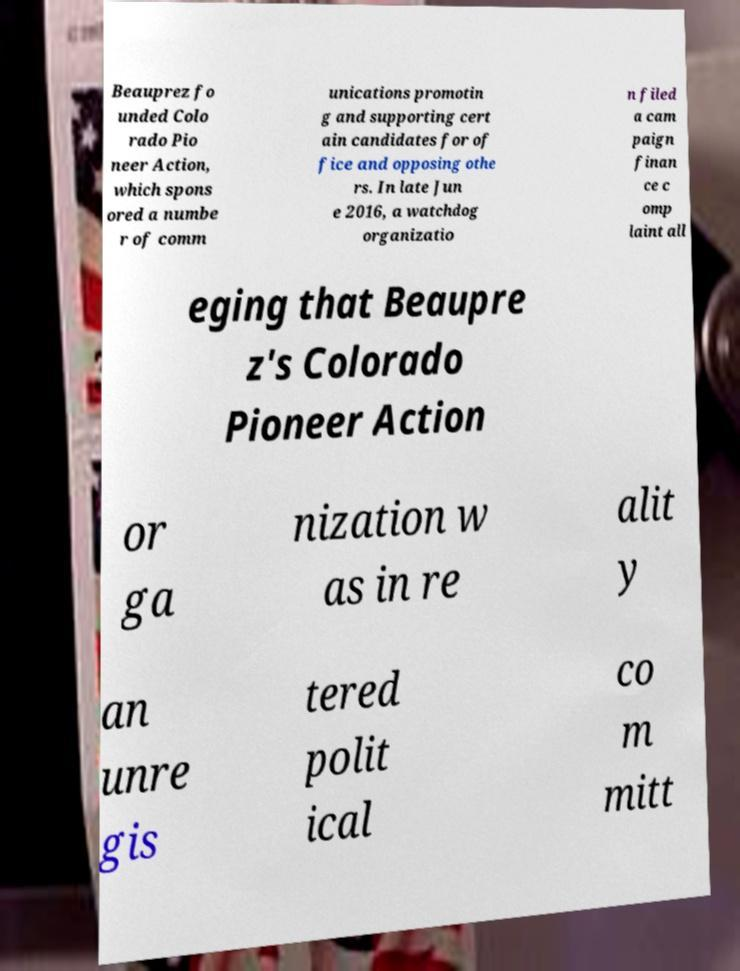Can you read and provide the text displayed in the image?This photo seems to have some interesting text. Can you extract and type it out for me? Beauprez fo unded Colo rado Pio neer Action, which spons ored a numbe r of comm unications promotin g and supporting cert ain candidates for of fice and opposing othe rs. In late Jun e 2016, a watchdog organizatio n filed a cam paign finan ce c omp laint all eging that Beaupre z's Colorado Pioneer Action or ga nization w as in re alit y an unre gis tered polit ical co m mitt 